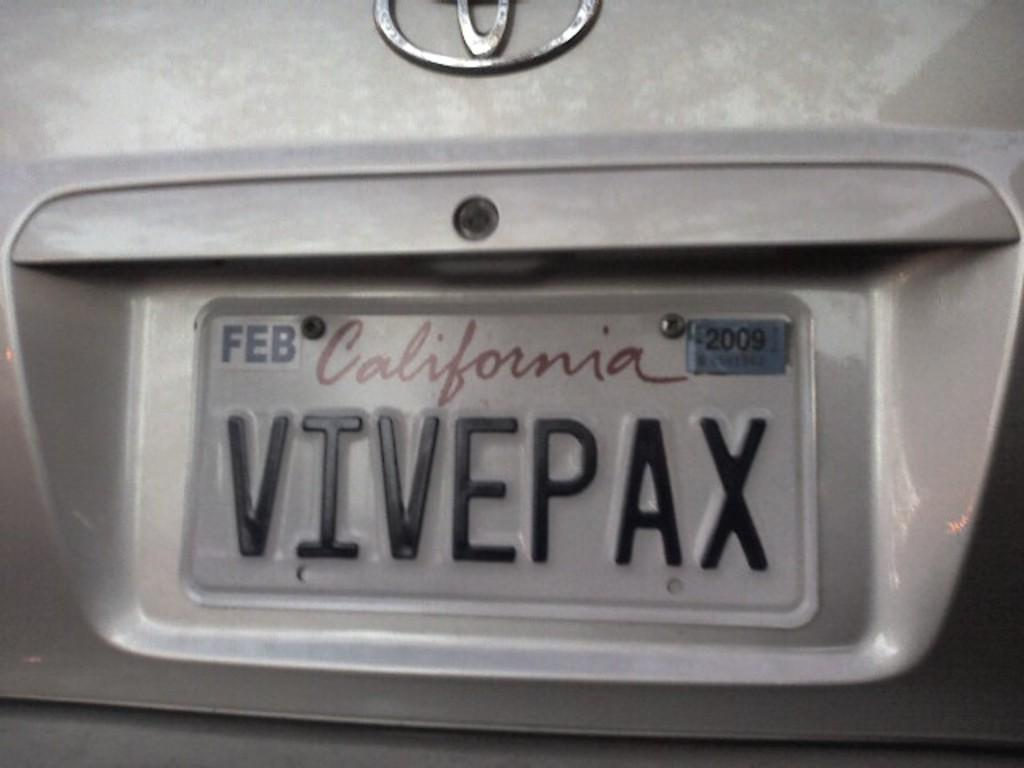<image>
Share a concise interpretation of the image provided. The California license plate has expired tags on it. 